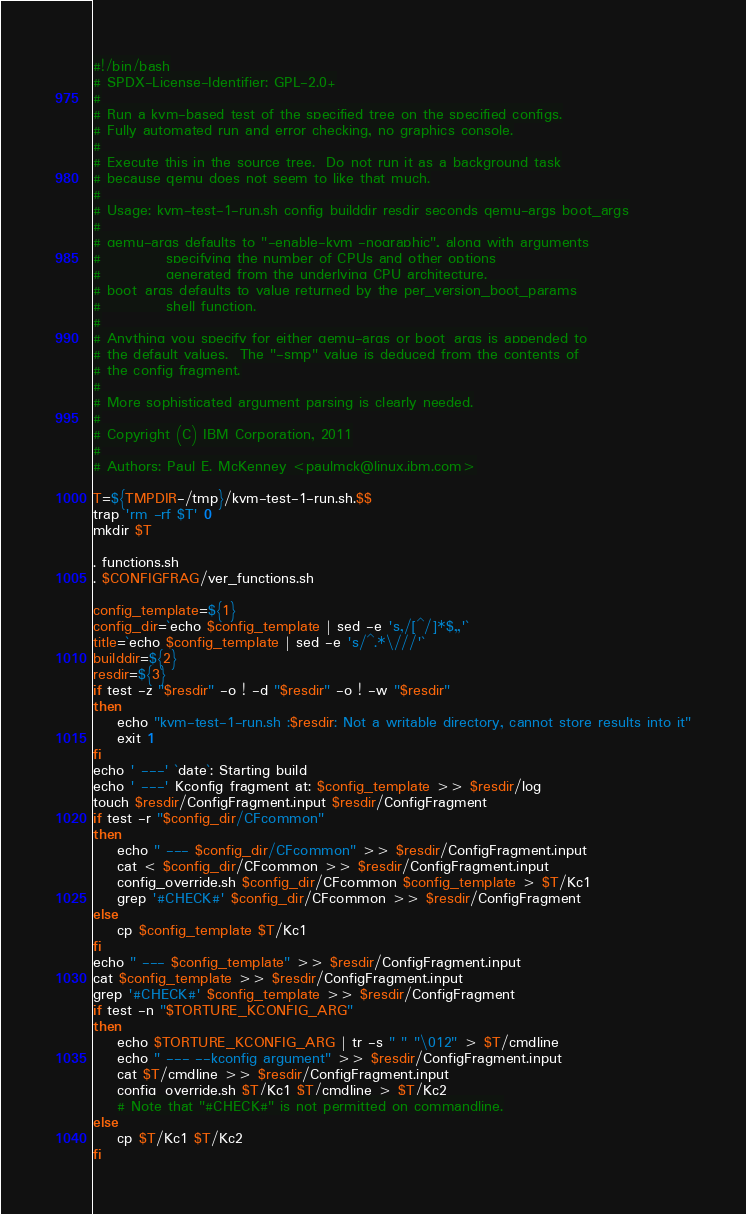<code> <loc_0><loc_0><loc_500><loc_500><_Bash_>#!/bin/bash
# SPDX-License-Identifier: GPL-2.0+
#
# Run a kvm-based test of the specified tree on the specified configs.
# Fully automated run and error checking, no graphics console.
#
# Execute this in the source tree.  Do not run it as a background task
# because qemu does not seem to like that much.
#
# Usage: kvm-test-1-run.sh config builddir resdir seconds qemu-args boot_args
#
# qemu-args defaults to "-enable-kvm -nographic", along with arguments
#			specifying the number of CPUs and other options
#			generated from the underlying CPU architecture.
# boot_args defaults to value returned by the per_version_boot_params
#			shell function.
#
# Anything you specify for either qemu-args or boot_args is appended to
# the default values.  The "-smp" value is deduced from the contents of
# the config fragment.
#
# More sophisticated argument parsing is clearly needed.
#
# Copyright (C) IBM Corporation, 2011
#
# Authors: Paul E. McKenney <paulmck@linux.ibm.com>

T=${TMPDIR-/tmp}/kvm-test-1-run.sh.$$
trap 'rm -rf $T' 0
mkdir $T

. functions.sh
. $CONFIGFRAG/ver_functions.sh

config_template=${1}
config_dir=`echo $config_template | sed -e 's,/[^/]*$,,'`
title=`echo $config_template | sed -e 's/^.*\///'`
builddir=${2}
resdir=${3}
if test -z "$resdir" -o ! -d "$resdir" -o ! -w "$resdir"
then
	echo "kvm-test-1-run.sh :$resdir: Not a writable directory, cannot store results into it"
	exit 1
fi
echo ' ---' `date`: Starting build
echo ' ---' Kconfig fragment at: $config_template >> $resdir/log
touch $resdir/ConfigFragment.input $resdir/ConfigFragment
if test -r "$config_dir/CFcommon"
then
	echo " --- $config_dir/CFcommon" >> $resdir/ConfigFragment.input
	cat < $config_dir/CFcommon >> $resdir/ConfigFragment.input
	config_override.sh $config_dir/CFcommon $config_template > $T/Kc1
	grep '#CHECK#' $config_dir/CFcommon >> $resdir/ConfigFragment
else
	cp $config_template $T/Kc1
fi
echo " --- $config_template" >> $resdir/ConfigFragment.input
cat $config_template >> $resdir/ConfigFragment.input
grep '#CHECK#' $config_template >> $resdir/ConfigFragment
if test -n "$TORTURE_KCONFIG_ARG"
then
	echo $TORTURE_KCONFIG_ARG | tr -s " " "\012" > $T/cmdline
	echo " --- --kconfig argument" >> $resdir/ConfigFragment.input
	cat $T/cmdline >> $resdir/ConfigFragment.input
	config_override.sh $T/Kc1 $T/cmdline > $T/Kc2
	# Note that "#CHECK#" is not permitted on commandline.
else
	cp $T/Kc1 $T/Kc2
fi</code> 